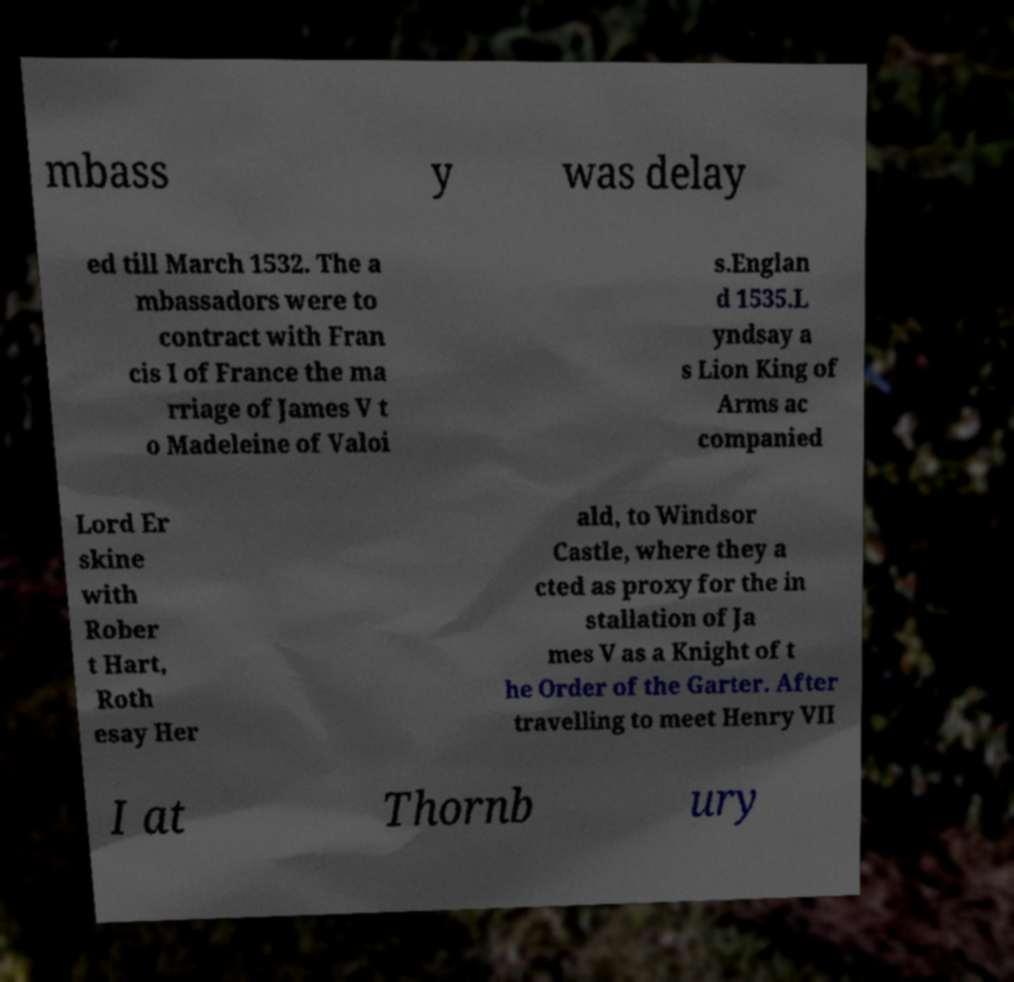Please read and relay the text visible in this image. What does it say? mbass y was delay ed till March 1532. The a mbassadors were to contract with Fran cis I of France the ma rriage of James V t o Madeleine of Valoi s.Englan d 1535.L yndsay a s Lion King of Arms ac companied Lord Er skine with Rober t Hart, Roth esay Her ald, to Windsor Castle, where they a cted as proxy for the in stallation of Ja mes V as a Knight of t he Order of the Garter. After travelling to meet Henry VII I at Thornb ury 